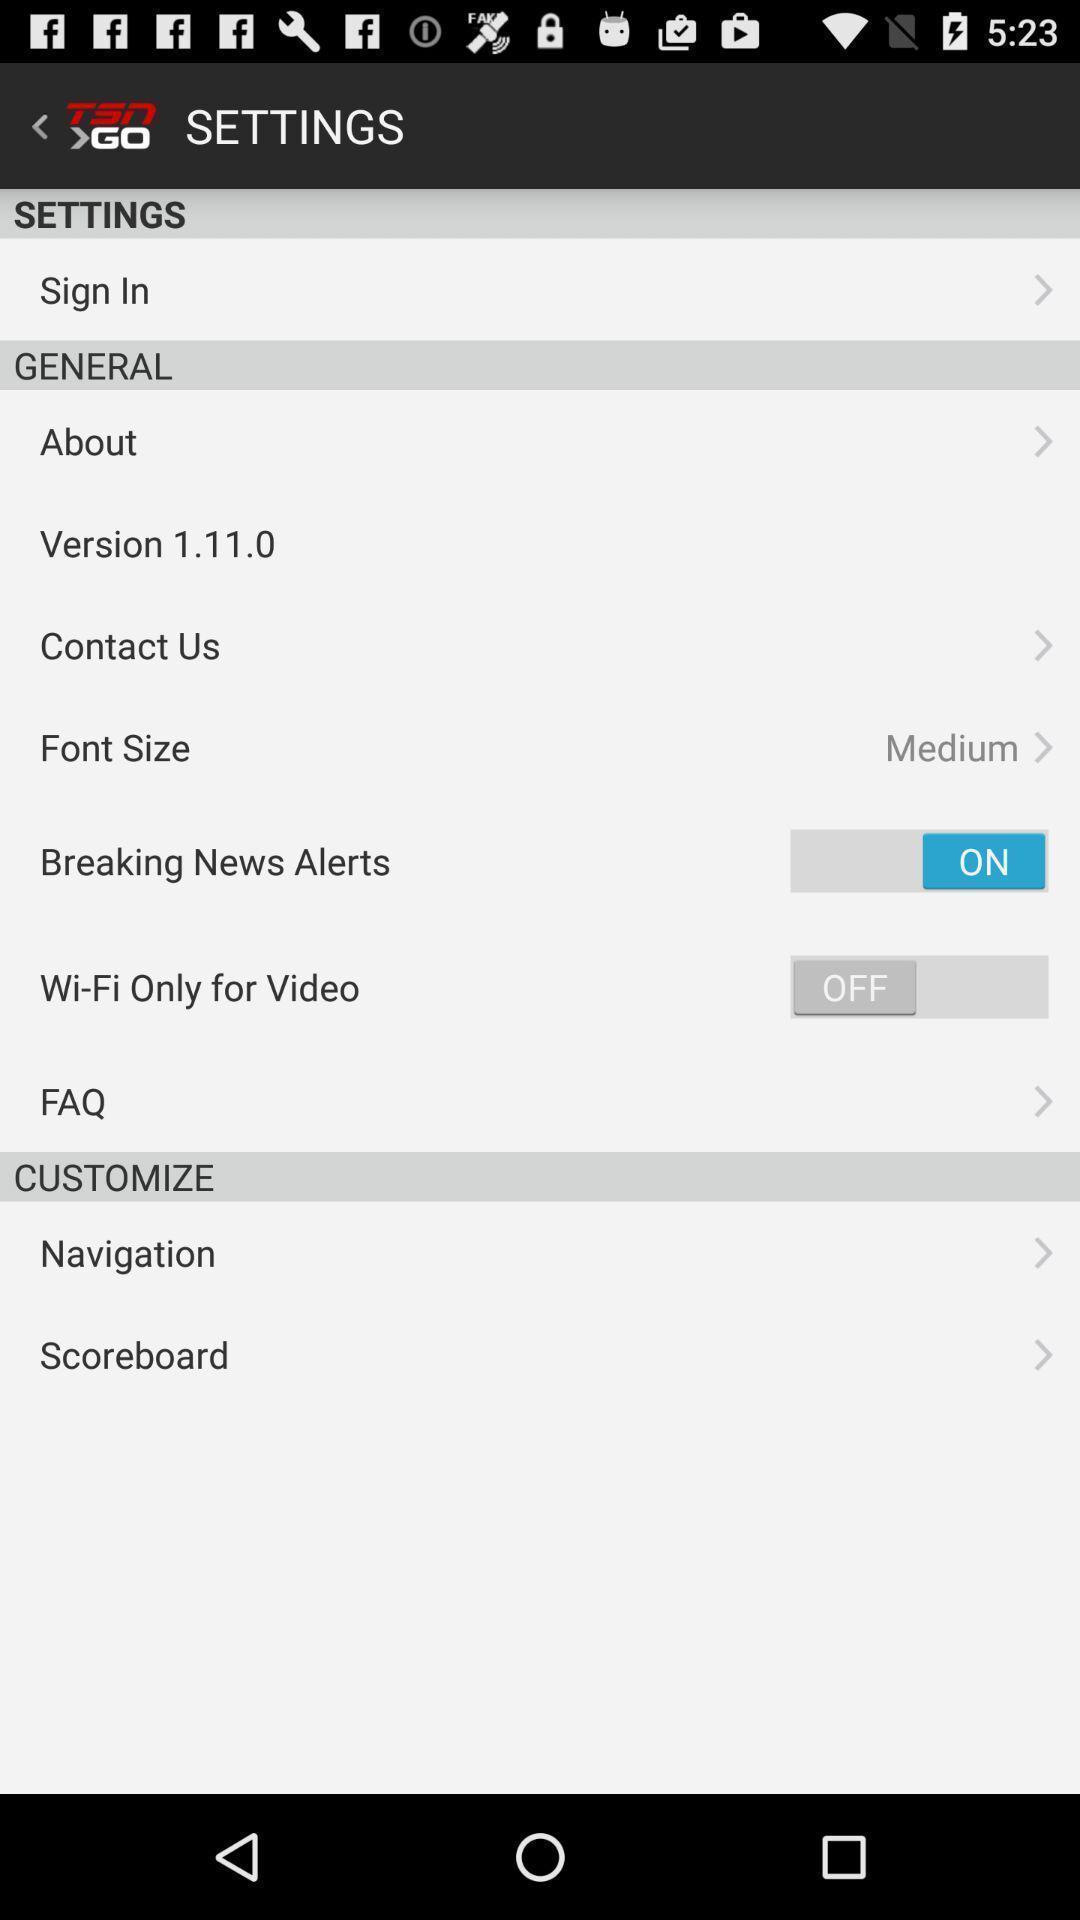Provide a description of this screenshot. Settings page of a sports application. 